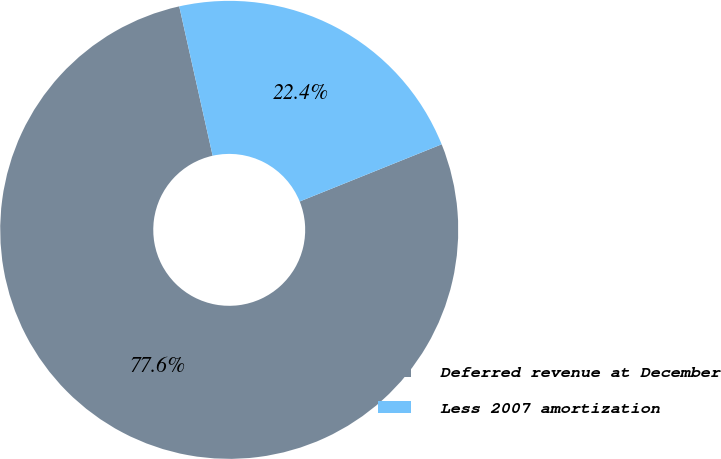Convert chart to OTSL. <chart><loc_0><loc_0><loc_500><loc_500><pie_chart><fcel>Deferred revenue at December<fcel>Less 2007 amortization<nl><fcel>77.59%<fcel>22.41%<nl></chart> 